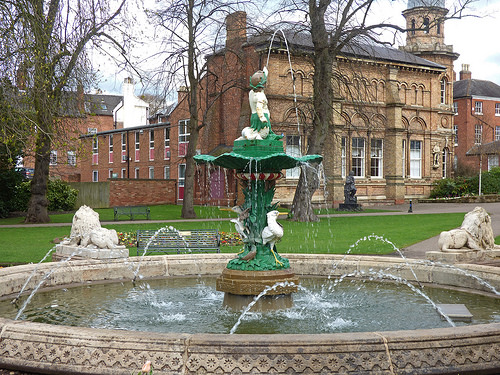<image>
Is the statue behind the water? No. The statue is not behind the water. From this viewpoint, the statue appears to be positioned elsewhere in the scene. 